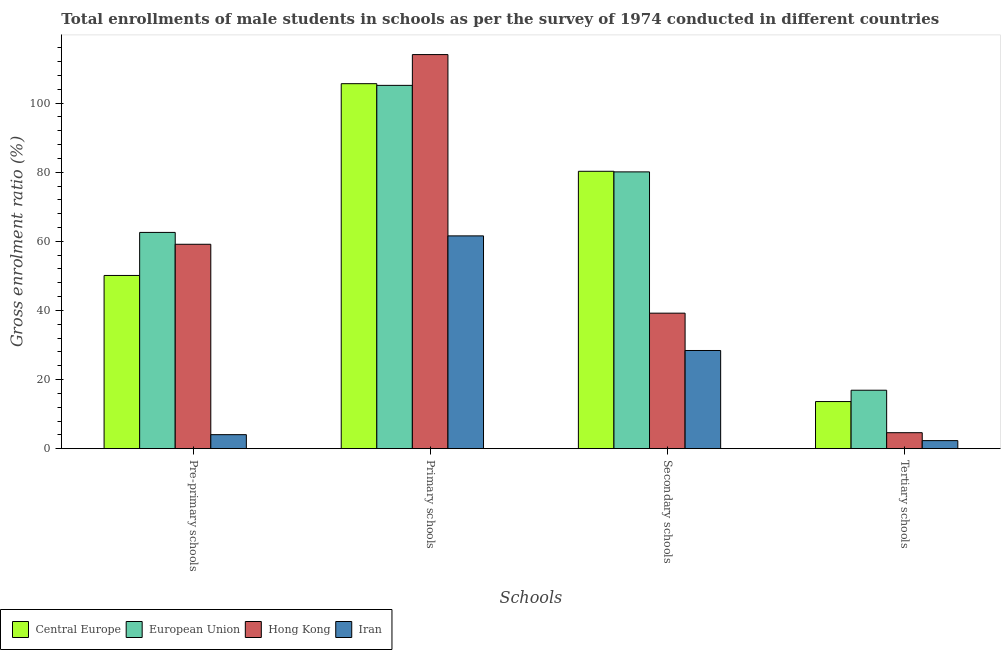Are the number of bars on each tick of the X-axis equal?
Your answer should be compact. Yes. How many bars are there on the 4th tick from the left?
Make the answer very short. 4. What is the label of the 3rd group of bars from the left?
Offer a very short reply. Secondary schools. What is the gross enrolment ratio(male) in secondary schools in Iran?
Your response must be concise. 28.41. Across all countries, what is the maximum gross enrolment ratio(male) in secondary schools?
Give a very brief answer. 80.27. Across all countries, what is the minimum gross enrolment ratio(male) in primary schools?
Ensure brevity in your answer.  61.58. In which country was the gross enrolment ratio(male) in tertiary schools maximum?
Offer a terse response. European Union. In which country was the gross enrolment ratio(male) in pre-primary schools minimum?
Offer a terse response. Iran. What is the total gross enrolment ratio(male) in secondary schools in the graph?
Offer a very short reply. 228. What is the difference between the gross enrolment ratio(male) in primary schools in Iran and that in Hong Kong?
Keep it short and to the point. -52.47. What is the difference between the gross enrolment ratio(male) in pre-primary schools in Central Europe and the gross enrolment ratio(male) in secondary schools in Hong Kong?
Your answer should be compact. 10.91. What is the average gross enrolment ratio(male) in pre-primary schools per country?
Your response must be concise. 43.98. What is the difference between the gross enrolment ratio(male) in tertiary schools and gross enrolment ratio(male) in pre-primary schools in Hong Kong?
Offer a very short reply. -54.53. What is the ratio of the gross enrolment ratio(male) in pre-primary schools in European Union to that in Central Europe?
Keep it short and to the point. 1.25. Is the gross enrolment ratio(male) in tertiary schools in European Union less than that in Central Europe?
Give a very brief answer. No. What is the difference between the highest and the second highest gross enrolment ratio(male) in primary schools?
Your answer should be compact. 8.42. What is the difference between the highest and the lowest gross enrolment ratio(male) in primary schools?
Provide a succinct answer. 52.47. Is it the case that in every country, the sum of the gross enrolment ratio(male) in primary schools and gross enrolment ratio(male) in secondary schools is greater than the sum of gross enrolment ratio(male) in pre-primary schools and gross enrolment ratio(male) in tertiary schools?
Make the answer very short. No. What does the 4th bar from the left in Primary schools represents?
Provide a short and direct response. Iran. What does the 1st bar from the right in Secondary schools represents?
Offer a very short reply. Iran. What is the difference between two consecutive major ticks on the Y-axis?
Give a very brief answer. 20. Are the values on the major ticks of Y-axis written in scientific E-notation?
Keep it short and to the point. No. Does the graph contain grids?
Provide a short and direct response. No. How many legend labels are there?
Your response must be concise. 4. How are the legend labels stacked?
Provide a succinct answer. Horizontal. What is the title of the graph?
Your answer should be compact. Total enrollments of male students in schools as per the survey of 1974 conducted in different countries. What is the label or title of the X-axis?
Keep it short and to the point. Schools. What is the Gross enrolment ratio (%) of Central Europe in Pre-primary schools?
Offer a very short reply. 50.13. What is the Gross enrolment ratio (%) of European Union in Pre-primary schools?
Offer a very short reply. 62.58. What is the Gross enrolment ratio (%) in Hong Kong in Pre-primary schools?
Keep it short and to the point. 59.15. What is the Gross enrolment ratio (%) in Iran in Pre-primary schools?
Provide a short and direct response. 4.06. What is the Gross enrolment ratio (%) in Central Europe in Primary schools?
Provide a short and direct response. 105.62. What is the Gross enrolment ratio (%) in European Union in Primary schools?
Offer a terse response. 105.14. What is the Gross enrolment ratio (%) of Hong Kong in Primary schools?
Make the answer very short. 114.05. What is the Gross enrolment ratio (%) of Iran in Primary schools?
Your response must be concise. 61.58. What is the Gross enrolment ratio (%) in Central Europe in Secondary schools?
Provide a succinct answer. 80.27. What is the Gross enrolment ratio (%) in European Union in Secondary schools?
Your response must be concise. 80.1. What is the Gross enrolment ratio (%) in Hong Kong in Secondary schools?
Your answer should be compact. 39.22. What is the Gross enrolment ratio (%) in Iran in Secondary schools?
Provide a short and direct response. 28.41. What is the Gross enrolment ratio (%) in Central Europe in Tertiary schools?
Ensure brevity in your answer.  13.63. What is the Gross enrolment ratio (%) of European Union in Tertiary schools?
Provide a short and direct response. 16.91. What is the Gross enrolment ratio (%) of Hong Kong in Tertiary schools?
Provide a short and direct response. 4.62. What is the Gross enrolment ratio (%) of Iran in Tertiary schools?
Provide a succinct answer. 2.33. Across all Schools, what is the maximum Gross enrolment ratio (%) in Central Europe?
Your answer should be compact. 105.62. Across all Schools, what is the maximum Gross enrolment ratio (%) of European Union?
Keep it short and to the point. 105.14. Across all Schools, what is the maximum Gross enrolment ratio (%) in Hong Kong?
Ensure brevity in your answer.  114.05. Across all Schools, what is the maximum Gross enrolment ratio (%) in Iran?
Provide a short and direct response. 61.58. Across all Schools, what is the minimum Gross enrolment ratio (%) in Central Europe?
Your response must be concise. 13.63. Across all Schools, what is the minimum Gross enrolment ratio (%) in European Union?
Your response must be concise. 16.91. Across all Schools, what is the minimum Gross enrolment ratio (%) of Hong Kong?
Make the answer very short. 4.62. Across all Schools, what is the minimum Gross enrolment ratio (%) of Iran?
Keep it short and to the point. 2.33. What is the total Gross enrolment ratio (%) of Central Europe in the graph?
Provide a succinct answer. 249.66. What is the total Gross enrolment ratio (%) in European Union in the graph?
Offer a very short reply. 264.73. What is the total Gross enrolment ratio (%) in Hong Kong in the graph?
Your response must be concise. 217.04. What is the total Gross enrolment ratio (%) of Iran in the graph?
Offer a very short reply. 96.38. What is the difference between the Gross enrolment ratio (%) of Central Europe in Pre-primary schools and that in Primary schools?
Give a very brief answer. -55.5. What is the difference between the Gross enrolment ratio (%) of European Union in Pre-primary schools and that in Primary schools?
Your answer should be very brief. -42.56. What is the difference between the Gross enrolment ratio (%) of Hong Kong in Pre-primary schools and that in Primary schools?
Provide a succinct answer. -54.9. What is the difference between the Gross enrolment ratio (%) in Iran in Pre-primary schools and that in Primary schools?
Make the answer very short. -57.52. What is the difference between the Gross enrolment ratio (%) in Central Europe in Pre-primary schools and that in Secondary schools?
Give a very brief answer. -30.14. What is the difference between the Gross enrolment ratio (%) in European Union in Pre-primary schools and that in Secondary schools?
Give a very brief answer. -17.52. What is the difference between the Gross enrolment ratio (%) in Hong Kong in Pre-primary schools and that in Secondary schools?
Your response must be concise. 19.93. What is the difference between the Gross enrolment ratio (%) in Iran in Pre-primary schools and that in Secondary schools?
Your answer should be very brief. -24.36. What is the difference between the Gross enrolment ratio (%) of Central Europe in Pre-primary schools and that in Tertiary schools?
Give a very brief answer. 36.49. What is the difference between the Gross enrolment ratio (%) of European Union in Pre-primary schools and that in Tertiary schools?
Give a very brief answer. 45.67. What is the difference between the Gross enrolment ratio (%) of Hong Kong in Pre-primary schools and that in Tertiary schools?
Give a very brief answer. 54.53. What is the difference between the Gross enrolment ratio (%) of Iran in Pre-primary schools and that in Tertiary schools?
Offer a very short reply. 1.72. What is the difference between the Gross enrolment ratio (%) of Central Europe in Primary schools and that in Secondary schools?
Ensure brevity in your answer.  25.35. What is the difference between the Gross enrolment ratio (%) of European Union in Primary schools and that in Secondary schools?
Your answer should be compact. 25.04. What is the difference between the Gross enrolment ratio (%) of Hong Kong in Primary schools and that in Secondary schools?
Make the answer very short. 74.83. What is the difference between the Gross enrolment ratio (%) of Iran in Primary schools and that in Secondary schools?
Your answer should be compact. 33.17. What is the difference between the Gross enrolment ratio (%) in Central Europe in Primary schools and that in Tertiary schools?
Provide a short and direct response. 91.99. What is the difference between the Gross enrolment ratio (%) in European Union in Primary schools and that in Tertiary schools?
Give a very brief answer. 88.23. What is the difference between the Gross enrolment ratio (%) in Hong Kong in Primary schools and that in Tertiary schools?
Your answer should be very brief. 109.42. What is the difference between the Gross enrolment ratio (%) of Iran in Primary schools and that in Tertiary schools?
Make the answer very short. 59.24. What is the difference between the Gross enrolment ratio (%) of Central Europe in Secondary schools and that in Tertiary schools?
Provide a short and direct response. 66.64. What is the difference between the Gross enrolment ratio (%) of European Union in Secondary schools and that in Tertiary schools?
Offer a terse response. 63.19. What is the difference between the Gross enrolment ratio (%) in Hong Kong in Secondary schools and that in Tertiary schools?
Keep it short and to the point. 34.59. What is the difference between the Gross enrolment ratio (%) in Iran in Secondary schools and that in Tertiary schools?
Ensure brevity in your answer.  26.08. What is the difference between the Gross enrolment ratio (%) of Central Europe in Pre-primary schools and the Gross enrolment ratio (%) of European Union in Primary schools?
Give a very brief answer. -55.01. What is the difference between the Gross enrolment ratio (%) in Central Europe in Pre-primary schools and the Gross enrolment ratio (%) in Hong Kong in Primary schools?
Your answer should be compact. -63.92. What is the difference between the Gross enrolment ratio (%) in Central Europe in Pre-primary schools and the Gross enrolment ratio (%) in Iran in Primary schools?
Your response must be concise. -11.45. What is the difference between the Gross enrolment ratio (%) of European Union in Pre-primary schools and the Gross enrolment ratio (%) of Hong Kong in Primary schools?
Provide a short and direct response. -51.46. What is the difference between the Gross enrolment ratio (%) of European Union in Pre-primary schools and the Gross enrolment ratio (%) of Iran in Primary schools?
Offer a very short reply. 1.01. What is the difference between the Gross enrolment ratio (%) in Hong Kong in Pre-primary schools and the Gross enrolment ratio (%) in Iran in Primary schools?
Your answer should be very brief. -2.43. What is the difference between the Gross enrolment ratio (%) in Central Europe in Pre-primary schools and the Gross enrolment ratio (%) in European Union in Secondary schools?
Your response must be concise. -29.97. What is the difference between the Gross enrolment ratio (%) of Central Europe in Pre-primary schools and the Gross enrolment ratio (%) of Hong Kong in Secondary schools?
Make the answer very short. 10.91. What is the difference between the Gross enrolment ratio (%) in Central Europe in Pre-primary schools and the Gross enrolment ratio (%) in Iran in Secondary schools?
Keep it short and to the point. 21.71. What is the difference between the Gross enrolment ratio (%) in European Union in Pre-primary schools and the Gross enrolment ratio (%) in Hong Kong in Secondary schools?
Provide a succinct answer. 23.37. What is the difference between the Gross enrolment ratio (%) in European Union in Pre-primary schools and the Gross enrolment ratio (%) in Iran in Secondary schools?
Give a very brief answer. 34.17. What is the difference between the Gross enrolment ratio (%) in Hong Kong in Pre-primary schools and the Gross enrolment ratio (%) in Iran in Secondary schools?
Keep it short and to the point. 30.74. What is the difference between the Gross enrolment ratio (%) of Central Europe in Pre-primary schools and the Gross enrolment ratio (%) of European Union in Tertiary schools?
Make the answer very short. 33.21. What is the difference between the Gross enrolment ratio (%) of Central Europe in Pre-primary schools and the Gross enrolment ratio (%) of Hong Kong in Tertiary schools?
Your answer should be very brief. 45.5. What is the difference between the Gross enrolment ratio (%) of Central Europe in Pre-primary schools and the Gross enrolment ratio (%) of Iran in Tertiary schools?
Your answer should be very brief. 47.79. What is the difference between the Gross enrolment ratio (%) in European Union in Pre-primary schools and the Gross enrolment ratio (%) in Hong Kong in Tertiary schools?
Provide a short and direct response. 57.96. What is the difference between the Gross enrolment ratio (%) in European Union in Pre-primary schools and the Gross enrolment ratio (%) in Iran in Tertiary schools?
Keep it short and to the point. 60.25. What is the difference between the Gross enrolment ratio (%) of Hong Kong in Pre-primary schools and the Gross enrolment ratio (%) of Iran in Tertiary schools?
Your response must be concise. 56.82. What is the difference between the Gross enrolment ratio (%) of Central Europe in Primary schools and the Gross enrolment ratio (%) of European Union in Secondary schools?
Give a very brief answer. 25.52. What is the difference between the Gross enrolment ratio (%) of Central Europe in Primary schools and the Gross enrolment ratio (%) of Hong Kong in Secondary schools?
Keep it short and to the point. 66.41. What is the difference between the Gross enrolment ratio (%) of Central Europe in Primary schools and the Gross enrolment ratio (%) of Iran in Secondary schools?
Ensure brevity in your answer.  77.21. What is the difference between the Gross enrolment ratio (%) in European Union in Primary schools and the Gross enrolment ratio (%) in Hong Kong in Secondary schools?
Give a very brief answer. 65.92. What is the difference between the Gross enrolment ratio (%) in European Union in Primary schools and the Gross enrolment ratio (%) in Iran in Secondary schools?
Your answer should be compact. 76.73. What is the difference between the Gross enrolment ratio (%) of Hong Kong in Primary schools and the Gross enrolment ratio (%) of Iran in Secondary schools?
Keep it short and to the point. 85.63. What is the difference between the Gross enrolment ratio (%) in Central Europe in Primary schools and the Gross enrolment ratio (%) in European Union in Tertiary schools?
Provide a succinct answer. 88.71. What is the difference between the Gross enrolment ratio (%) of Central Europe in Primary schools and the Gross enrolment ratio (%) of Hong Kong in Tertiary schools?
Give a very brief answer. 101. What is the difference between the Gross enrolment ratio (%) in Central Europe in Primary schools and the Gross enrolment ratio (%) in Iran in Tertiary schools?
Your response must be concise. 103.29. What is the difference between the Gross enrolment ratio (%) in European Union in Primary schools and the Gross enrolment ratio (%) in Hong Kong in Tertiary schools?
Ensure brevity in your answer.  100.51. What is the difference between the Gross enrolment ratio (%) of European Union in Primary schools and the Gross enrolment ratio (%) of Iran in Tertiary schools?
Give a very brief answer. 102.81. What is the difference between the Gross enrolment ratio (%) of Hong Kong in Primary schools and the Gross enrolment ratio (%) of Iran in Tertiary schools?
Make the answer very short. 111.71. What is the difference between the Gross enrolment ratio (%) of Central Europe in Secondary schools and the Gross enrolment ratio (%) of European Union in Tertiary schools?
Give a very brief answer. 63.36. What is the difference between the Gross enrolment ratio (%) of Central Europe in Secondary schools and the Gross enrolment ratio (%) of Hong Kong in Tertiary schools?
Offer a terse response. 75.65. What is the difference between the Gross enrolment ratio (%) of Central Europe in Secondary schools and the Gross enrolment ratio (%) of Iran in Tertiary schools?
Provide a succinct answer. 77.94. What is the difference between the Gross enrolment ratio (%) of European Union in Secondary schools and the Gross enrolment ratio (%) of Hong Kong in Tertiary schools?
Give a very brief answer. 75.48. What is the difference between the Gross enrolment ratio (%) in European Union in Secondary schools and the Gross enrolment ratio (%) in Iran in Tertiary schools?
Give a very brief answer. 77.77. What is the difference between the Gross enrolment ratio (%) in Hong Kong in Secondary schools and the Gross enrolment ratio (%) in Iran in Tertiary schools?
Provide a succinct answer. 36.88. What is the average Gross enrolment ratio (%) in Central Europe per Schools?
Provide a short and direct response. 62.41. What is the average Gross enrolment ratio (%) of European Union per Schools?
Provide a short and direct response. 66.18. What is the average Gross enrolment ratio (%) in Hong Kong per Schools?
Give a very brief answer. 54.26. What is the average Gross enrolment ratio (%) of Iran per Schools?
Make the answer very short. 24.09. What is the difference between the Gross enrolment ratio (%) in Central Europe and Gross enrolment ratio (%) in European Union in Pre-primary schools?
Keep it short and to the point. -12.46. What is the difference between the Gross enrolment ratio (%) in Central Europe and Gross enrolment ratio (%) in Hong Kong in Pre-primary schools?
Your answer should be very brief. -9.02. What is the difference between the Gross enrolment ratio (%) of Central Europe and Gross enrolment ratio (%) of Iran in Pre-primary schools?
Your answer should be very brief. 46.07. What is the difference between the Gross enrolment ratio (%) of European Union and Gross enrolment ratio (%) of Hong Kong in Pre-primary schools?
Offer a terse response. 3.43. What is the difference between the Gross enrolment ratio (%) of European Union and Gross enrolment ratio (%) of Iran in Pre-primary schools?
Your response must be concise. 58.53. What is the difference between the Gross enrolment ratio (%) in Hong Kong and Gross enrolment ratio (%) in Iran in Pre-primary schools?
Give a very brief answer. 55.09. What is the difference between the Gross enrolment ratio (%) in Central Europe and Gross enrolment ratio (%) in European Union in Primary schools?
Your response must be concise. 0.49. What is the difference between the Gross enrolment ratio (%) of Central Europe and Gross enrolment ratio (%) of Hong Kong in Primary schools?
Keep it short and to the point. -8.42. What is the difference between the Gross enrolment ratio (%) of Central Europe and Gross enrolment ratio (%) of Iran in Primary schools?
Provide a short and direct response. 44.05. What is the difference between the Gross enrolment ratio (%) of European Union and Gross enrolment ratio (%) of Hong Kong in Primary schools?
Provide a succinct answer. -8.91. What is the difference between the Gross enrolment ratio (%) in European Union and Gross enrolment ratio (%) in Iran in Primary schools?
Your answer should be compact. 43.56. What is the difference between the Gross enrolment ratio (%) in Hong Kong and Gross enrolment ratio (%) in Iran in Primary schools?
Make the answer very short. 52.47. What is the difference between the Gross enrolment ratio (%) of Central Europe and Gross enrolment ratio (%) of European Union in Secondary schools?
Provide a short and direct response. 0.17. What is the difference between the Gross enrolment ratio (%) of Central Europe and Gross enrolment ratio (%) of Hong Kong in Secondary schools?
Your answer should be compact. 41.05. What is the difference between the Gross enrolment ratio (%) of Central Europe and Gross enrolment ratio (%) of Iran in Secondary schools?
Offer a terse response. 51.86. What is the difference between the Gross enrolment ratio (%) in European Union and Gross enrolment ratio (%) in Hong Kong in Secondary schools?
Your answer should be compact. 40.88. What is the difference between the Gross enrolment ratio (%) of European Union and Gross enrolment ratio (%) of Iran in Secondary schools?
Make the answer very short. 51.69. What is the difference between the Gross enrolment ratio (%) of Hong Kong and Gross enrolment ratio (%) of Iran in Secondary schools?
Your response must be concise. 10.8. What is the difference between the Gross enrolment ratio (%) in Central Europe and Gross enrolment ratio (%) in European Union in Tertiary schools?
Your answer should be very brief. -3.28. What is the difference between the Gross enrolment ratio (%) in Central Europe and Gross enrolment ratio (%) in Hong Kong in Tertiary schools?
Give a very brief answer. 9.01. What is the difference between the Gross enrolment ratio (%) in Central Europe and Gross enrolment ratio (%) in Iran in Tertiary schools?
Keep it short and to the point. 11.3. What is the difference between the Gross enrolment ratio (%) in European Union and Gross enrolment ratio (%) in Hong Kong in Tertiary schools?
Provide a short and direct response. 12.29. What is the difference between the Gross enrolment ratio (%) of European Union and Gross enrolment ratio (%) of Iran in Tertiary schools?
Make the answer very short. 14.58. What is the difference between the Gross enrolment ratio (%) of Hong Kong and Gross enrolment ratio (%) of Iran in Tertiary schools?
Offer a very short reply. 2.29. What is the ratio of the Gross enrolment ratio (%) of Central Europe in Pre-primary schools to that in Primary schools?
Your response must be concise. 0.47. What is the ratio of the Gross enrolment ratio (%) of European Union in Pre-primary schools to that in Primary schools?
Your answer should be compact. 0.6. What is the ratio of the Gross enrolment ratio (%) in Hong Kong in Pre-primary schools to that in Primary schools?
Offer a terse response. 0.52. What is the ratio of the Gross enrolment ratio (%) in Iran in Pre-primary schools to that in Primary schools?
Your response must be concise. 0.07. What is the ratio of the Gross enrolment ratio (%) of Central Europe in Pre-primary schools to that in Secondary schools?
Give a very brief answer. 0.62. What is the ratio of the Gross enrolment ratio (%) of European Union in Pre-primary schools to that in Secondary schools?
Keep it short and to the point. 0.78. What is the ratio of the Gross enrolment ratio (%) of Hong Kong in Pre-primary schools to that in Secondary schools?
Your response must be concise. 1.51. What is the ratio of the Gross enrolment ratio (%) in Iran in Pre-primary schools to that in Secondary schools?
Your answer should be compact. 0.14. What is the ratio of the Gross enrolment ratio (%) of Central Europe in Pre-primary schools to that in Tertiary schools?
Offer a very short reply. 3.68. What is the ratio of the Gross enrolment ratio (%) in European Union in Pre-primary schools to that in Tertiary schools?
Make the answer very short. 3.7. What is the ratio of the Gross enrolment ratio (%) in Hong Kong in Pre-primary schools to that in Tertiary schools?
Offer a very short reply. 12.79. What is the ratio of the Gross enrolment ratio (%) of Iran in Pre-primary schools to that in Tertiary schools?
Ensure brevity in your answer.  1.74. What is the ratio of the Gross enrolment ratio (%) of Central Europe in Primary schools to that in Secondary schools?
Keep it short and to the point. 1.32. What is the ratio of the Gross enrolment ratio (%) of European Union in Primary schools to that in Secondary schools?
Your response must be concise. 1.31. What is the ratio of the Gross enrolment ratio (%) of Hong Kong in Primary schools to that in Secondary schools?
Provide a short and direct response. 2.91. What is the ratio of the Gross enrolment ratio (%) in Iran in Primary schools to that in Secondary schools?
Provide a short and direct response. 2.17. What is the ratio of the Gross enrolment ratio (%) in Central Europe in Primary schools to that in Tertiary schools?
Offer a terse response. 7.75. What is the ratio of the Gross enrolment ratio (%) in European Union in Primary schools to that in Tertiary schools?
Keep it short and to the point. 6.22. What is the ratio of the Gross enrolment ratio (%) of Hong Kong in Primary schools to that in Tertiary schools?
Offer a very short reply. 24.67. What is the ratio of the Gross enrolment ratio (%) of Iran in Primary schools to that in Tertiary schools?
Your response must be concise. 26.4. What is the ratio of the Gross enrolment ratio (%) of Central Europe in Secondary schools to that in Tertiary schools?
Make the answer very short. 5.89. What is the ratio of the Gross enrolment ratio (%) of European Union in Secondary schools to that in Tertiary schools?
Give a very brief answer. 4.74. What is the ratio of the Gross enrolment ratio (%) of Hong Kong in Secondary schools to that in Tertiary schools?
Ensure brevity in your answer.  8.48. What is the ratio of the Gross enrolment ratio (%) of Iran in Secondary schools to that in Tertiary schools?
Your response must be concise. 12.18. What is the difference between the highest and the second highest Gross enrolment ratio (%) of Central Europe?
Offer a terse response. 25.35. What is the difference between the highest and the second highest Gross enrolment ratio (%) of European Union?
Provide a short and direct response. 25.04. What is the difference between the highest and the second highest Gross enrolment ratio (%) in Hong Kong?
Make the answer very short. 54.9. What is the difference between the highest and the second highest Gross enrolment ratio (%) of Iran?
Give a very brief answer. 33.17. What is the difference between the highest and the lowest Gross enrolment ratio (%) of Central Europe?
Your answer should be very brief. 91.99. What is the difference between the highest and the lowest Gross enrolment ratio (%) in European Union?
Keep it short and to the point. 88.23. What is the difference between the highest and the lowest Gross enrolment ratio (%) of Hong Kong?
Your answer should be compact. 109.42. What is the difference between the highest and the lowest Gross enrolment ratio (%) in Iran?
Make the answer very short. 59.24. 